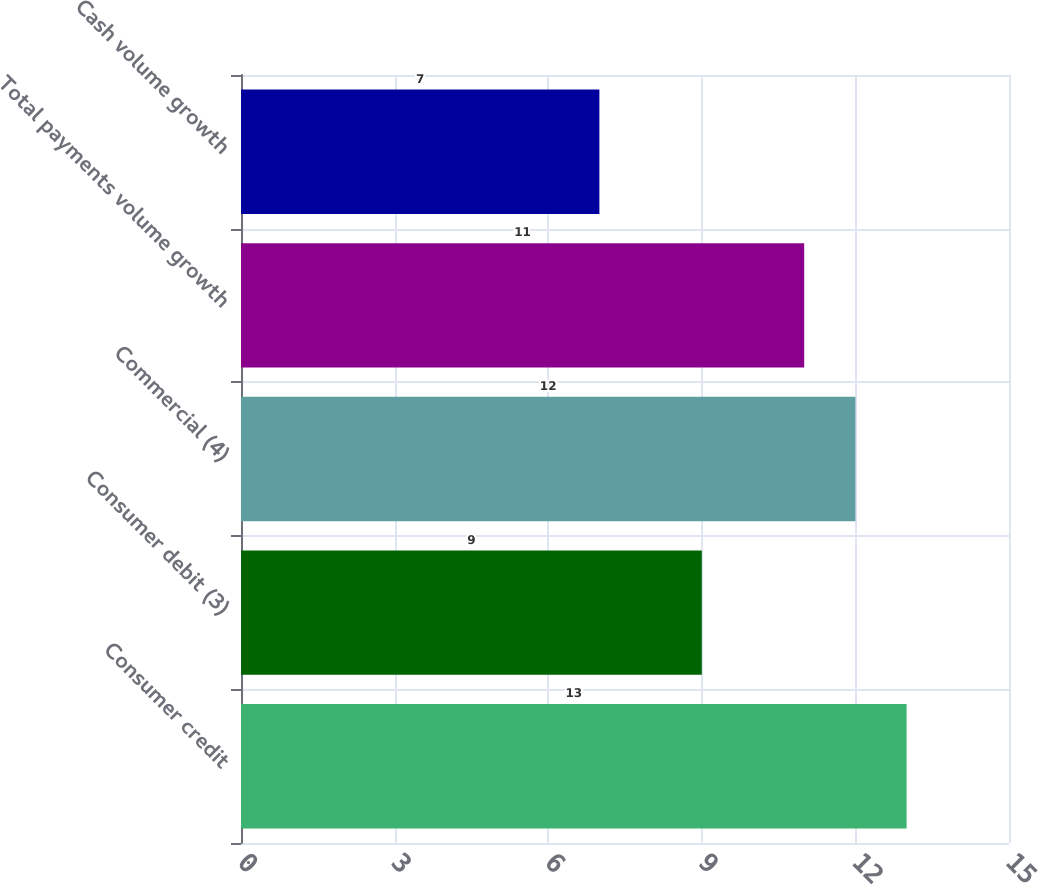Convert chart to OTSL. <chart><loc_0><loc_0><loc_500><loc_500><bar_chart><fcel>Consumer credit<fcel>Consumer debit (3)<fcel>Commercial (4)<fcel>Total payments volume growth<fcel>Cash volume growth<nl><fcel>13<fcel>9<fcel>12<fcel>11<fcel>7<nl></chart> 